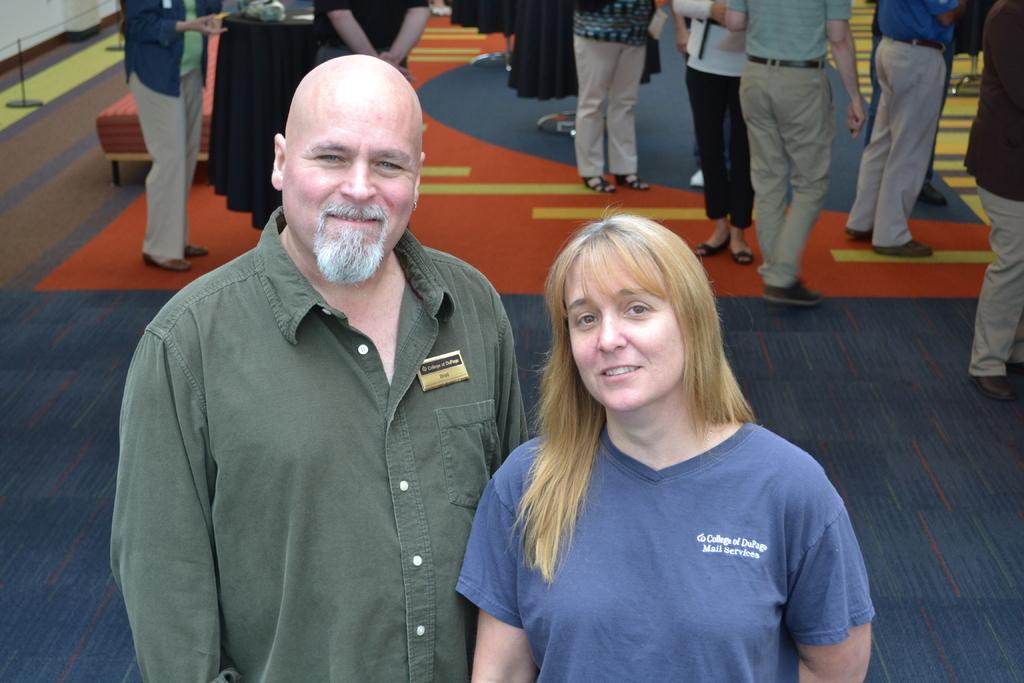Who is present in the image? There is a man and a woman in the image. What are the man and woman doing in the image? Both the man and woman are standing and smiling in the image. What can be seen in the background of the image? There is a group of people standing on the ground and objects visible in the background. What type of drain can be seen in the image? There is no drain present in the image. What material is the floor made of in the image? The image does not show the floor, so it cannot be determined what material it is made of. 